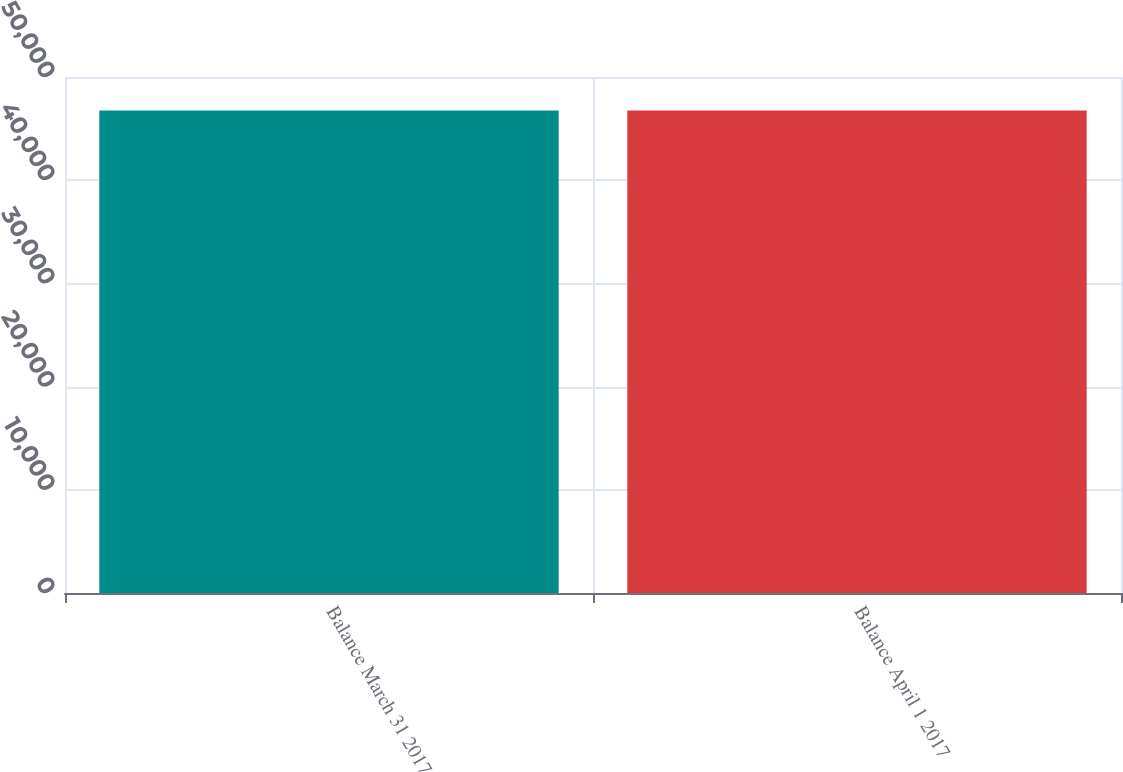Convert chart to OTSL. <chart><loc_0><loc_0><loc_500><loc_500><bar_chart><fcel>Balance March 31 2017<fcel>Balance April 1 2017<nl><fcel>46763<fcel>46763.1<nl></chart> 